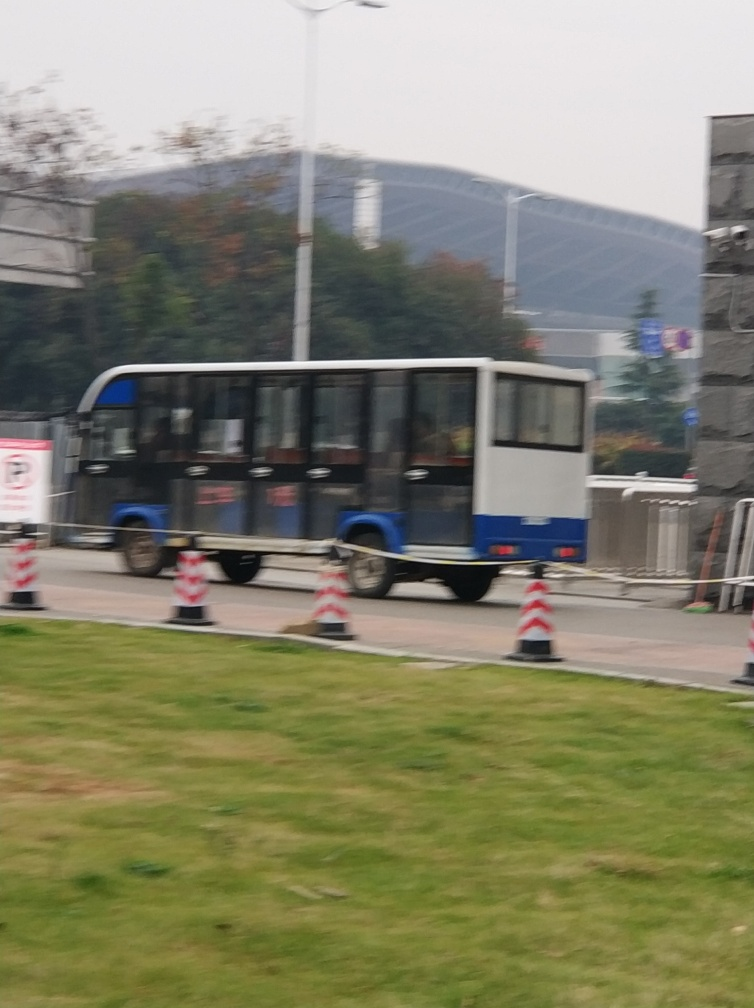What kind of weather conditions does the image imply? The image implies overcast or possibly polluted conditions as there is a significant amount of haze. This blurs the view and suggests that the air may be heavy with moisture or pollutants. Would the air quality affect physical activities in this area? Yes, poor air quality can deter outdoor physical activities by causing discomfort or health concerns. If the haziness is due to pollution, it could lead people to limit their time outside or engage in activities in indoor or cleaner areas. 